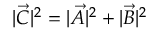<formula> <loc_0><loc_0><loc_500><loc_500>| { \vec { C } } | ^ { 2 } = | { \vec { A } } | ^ { 2 } + | { \vec { B } } | ^ { 2 }</formula> 